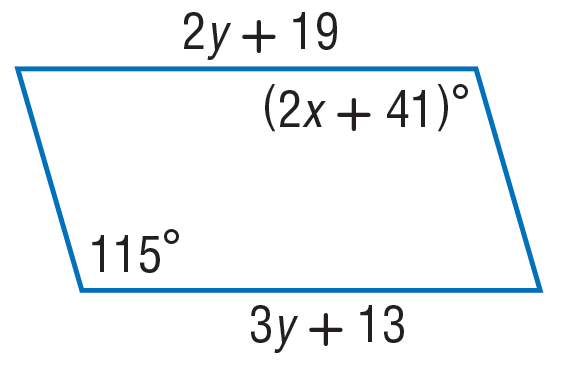Answer the mathemtical geometry problem and directly provide the correct option letter.
Question: Find y in the parallelogram.
Choices: A: 6 B: 12 C: 19 D: 115 A 